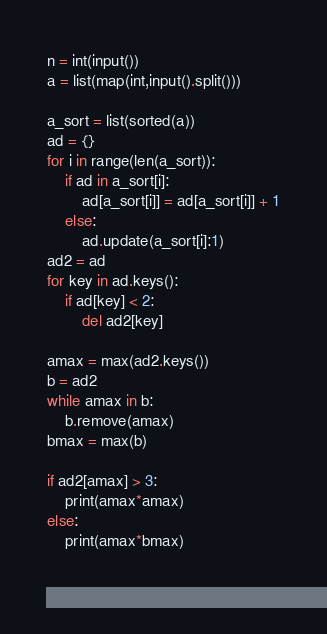Convert code to text. <code><loc_0><loc_0><loc_500><loc_500><_Python_>n = int(input())
a = list(map(int,input().split()))

a_sort = list(sorted(a))
ad = {}
for i in range(len(a_sort)):
    if ad in a_sort[i]:
        ad[a_sort[i]] = ad[a_sort[i]] + 1
    else:
        ad.update(a_sort[i]:1)
ad2 = ad
for key in ad.keys():
    if ad[key] < 2:
        del ad2[key]

amax = max(ad2.keys())
b = ad2
while amax in b:
    b.remove(amax)
bmax = max(b)

if ad2[amax] > 3:
    print(amax*amax)
else:
    print(amax*bmax)

         </code> 